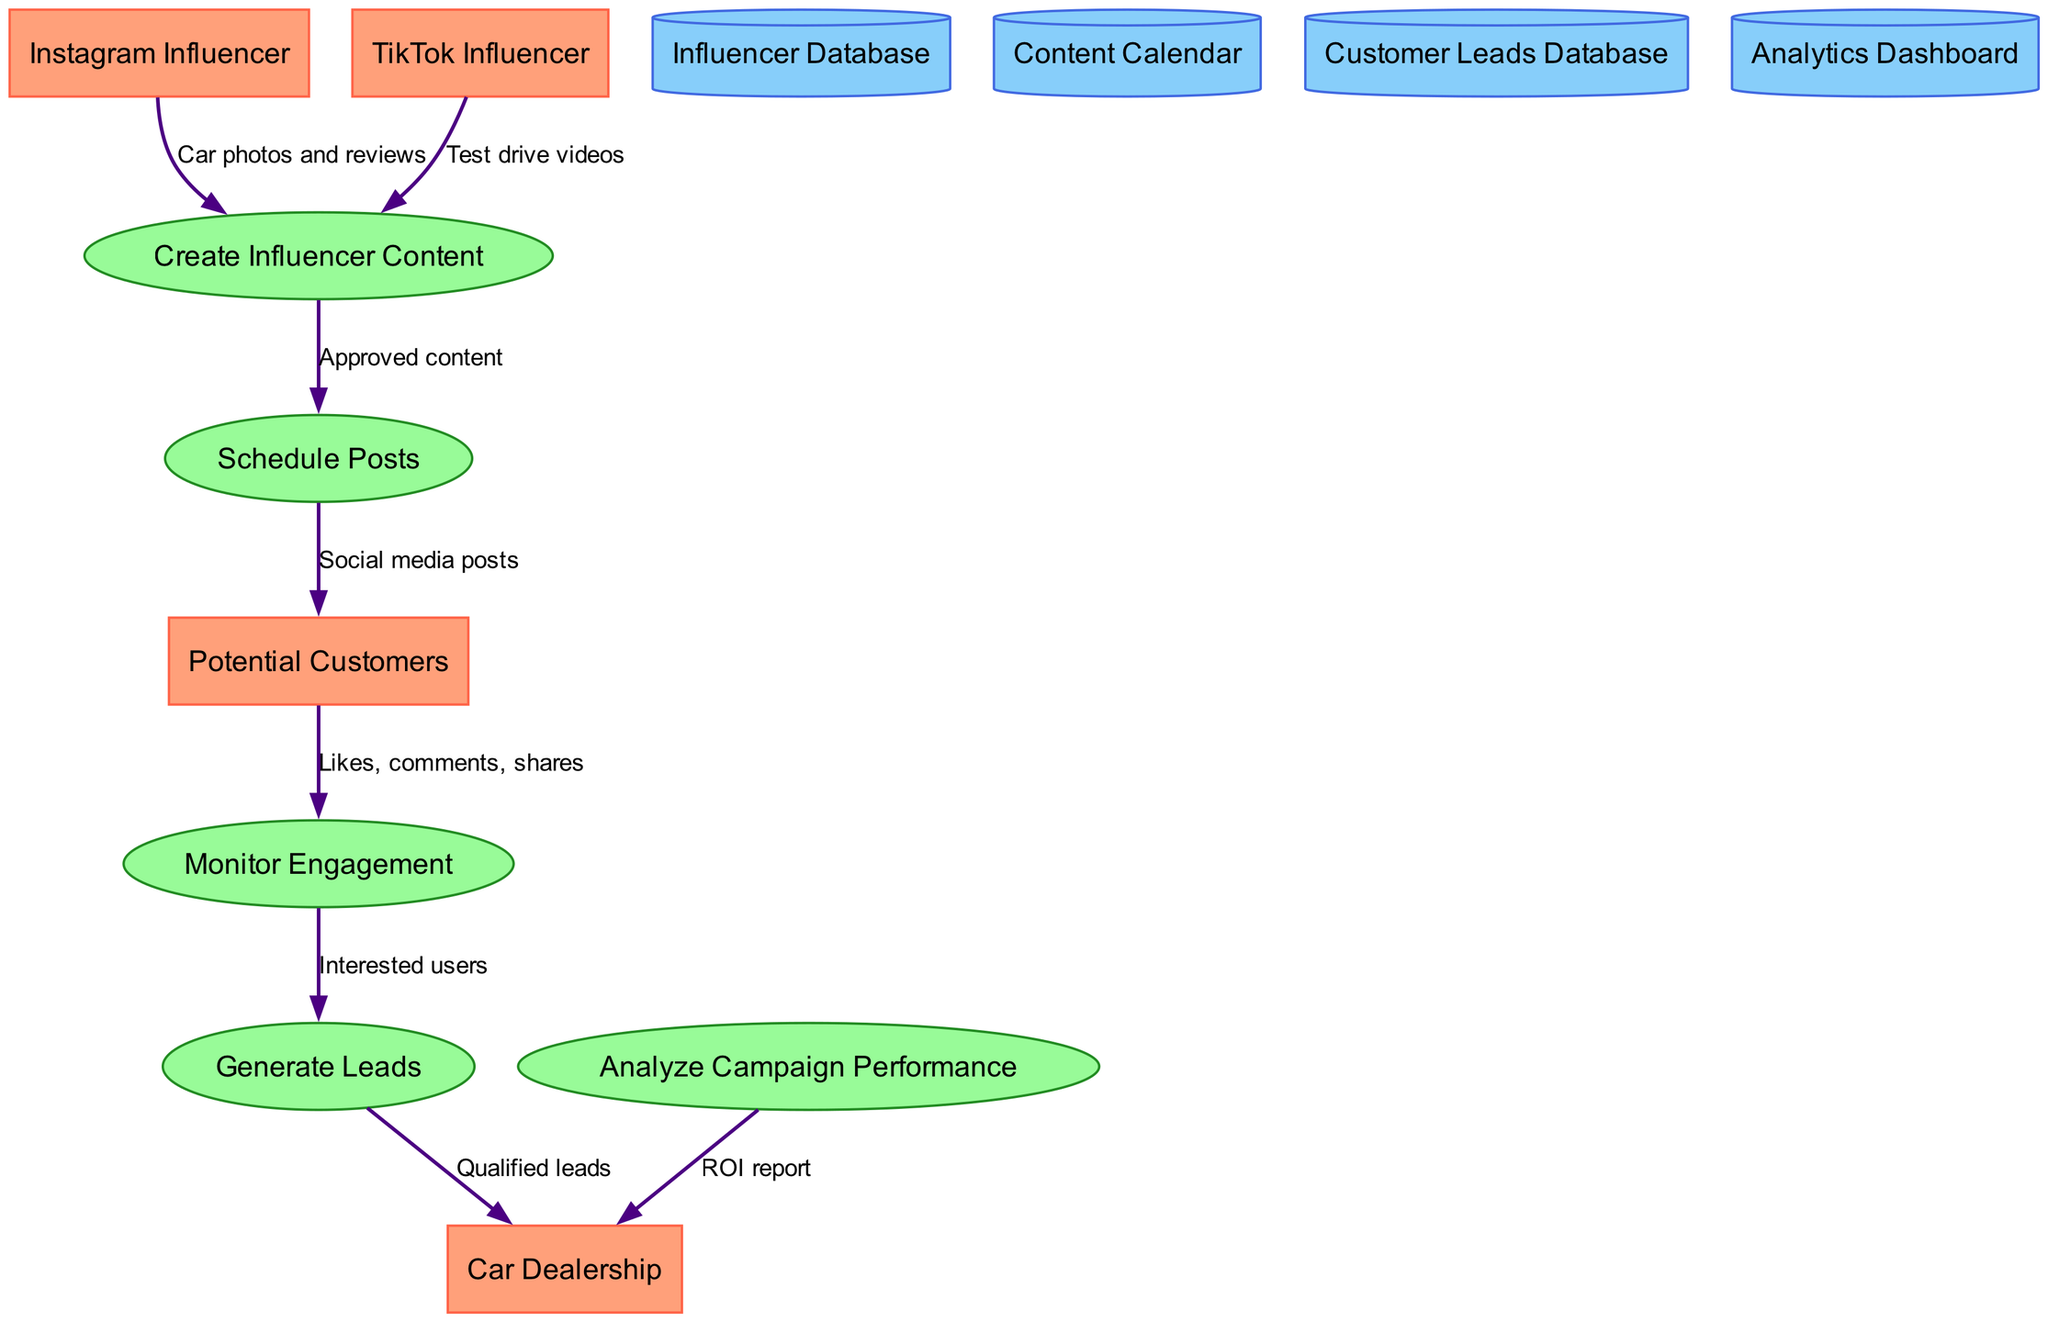What external entities are involved in the campaign? The external entities listed in the diagram are Instagram Influencer, TikTok Influencer, Potential Customers, and Car Dealership. These are identified at the beginning of the data flow diagram.
Answer: Instagram Influencer, TikTok Influencer, Potential Customers, Car Dealership How many processes are there in the diagram? The diagram includes five processes: Create Influencer Content, Schedule Posts, Monitor Engagement, Generate Leads, and Analyze Campaign Performance. Counting these processes gives a total number of five.
Answer: 5 What data flows from the TikTok Influencer to the Create Influencer Content process? The label on the data flow from the TikTok Influencer indicates that they provide "Test drive videos." This information is noted in the data flow connections depicted in the diagram.
Answer: Test drive videos Which process receives likes, comments, and shares from Potential Customers? The Monitor Engagement process receives the engagement data (likes, comments, shares) from Potential Customers, as indicated by the data flow connection.
Answer: Monitor Engagement What type of report is generated in the Analyze Campaign Performance process? The Analyze Campaign Performance process sends a report labeled "ROI report" to the Car Dealership, as detailed in the data flow connections.
Answer: ROI report What is the output of the Generate Leads process? The output from the Generate Leads process is "Qualified leads," which is sent to the Car Dealership based on the data flow depicted in the diagram.
Answer: Qualified leads Which data store holds the content planned for posting? The Content Calendar is the data store that holds the planned content for posting, as mentioned in the data store section of the diagram.
Answer: Content Calendar How does the Monitor Engagement process contribute to the sales lead generation? The Monitor Engagement process contributes to generating sales leads by providing "Interested users" to the Generate Leads process, highlighting the connection between these two processes.
Answer: Interested users 